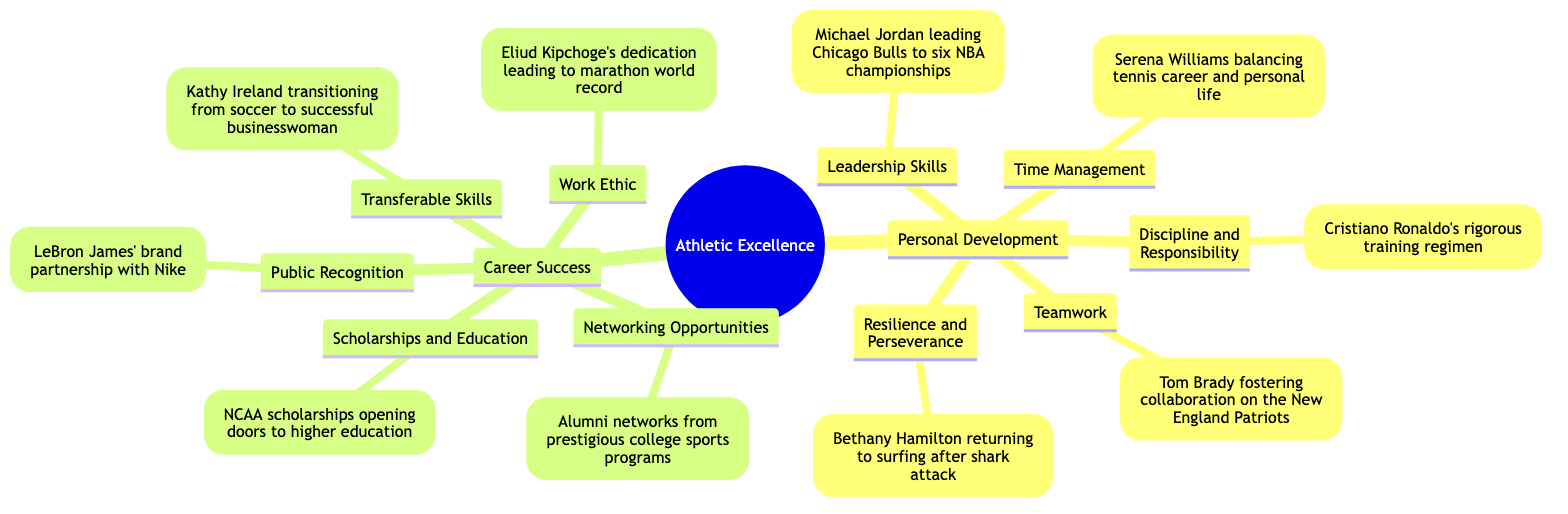What is an example of Leadership Skills? The diagram shows Michael Jordan leading the Chicago Bulls to six NBA championships as an example of Leadership Skills under Personal Development.
Answer: Michael Jordan leading Chicago Bulls to six NBA championships How many main categories are under Benefits of Athletic Excellence? The diagram displays two main categories: Personal Development and Career Success, indicating that there are two distinct areas.
Answer: 2 What is an example of Discipline and Responsibility? Cristiano Ronaldo's rigorous training regimen is listed as an example under Discipline and Responsibility in Personal Development, showcasing a commitment to training.
Answer: Cristiano Ronaldo's rigorous training regimen Which athlete is associated with Resilience and Perseverance? The diagram indicates that Bethany Hamilton is associated with Resilience and Perseverance, illustrating her return to surfing after a shark attack.
Answer: Bethany Hamilton returning to surfing after shark attack How does athletic excellence contribute to Career Success through Networking Opportunities? The diagram shows that Alumni networks from prestigious college sports programs serve as Networking Opportunities, highlighting how athletes can connect while pursuing careers.
Answer: Alumni networks from prestigious college sports programs What skills can be considered Transferable Skills according to the diagram? The diagram references Kathy Ireland's transition from soccer to being a successful businesswoman to illustrate the concept of Transferable Skills in Career Success.
Answer: Kathy Ireland transitioning from soccer to successful businesswoman What is the significance of Time Management in Personal Development? The diagram cites Serena Williams balancing her tennis career and personal life as an essential example demonstrating her Time Management skills.
Answer: Serena Williams balancing tennis career and personal life Who exemplifies Work Ethic in the context of athletic excellence? Eliud Kipchoge is highlighted as an example of Work Ethic through his dedication, which has led to a marathon world record, showcasing a strong drive and commitment.
Answer: Eliud Kipchoge's dedication leading to marathon world record What is an example of Public Recognition? The diagram mentions LeBron James' brand partnership with Nike as an example of Public Recognition, illustrating how athletic excellence can lead to celebrity status.
Answer: LeBron James' brand partnership with Nike 